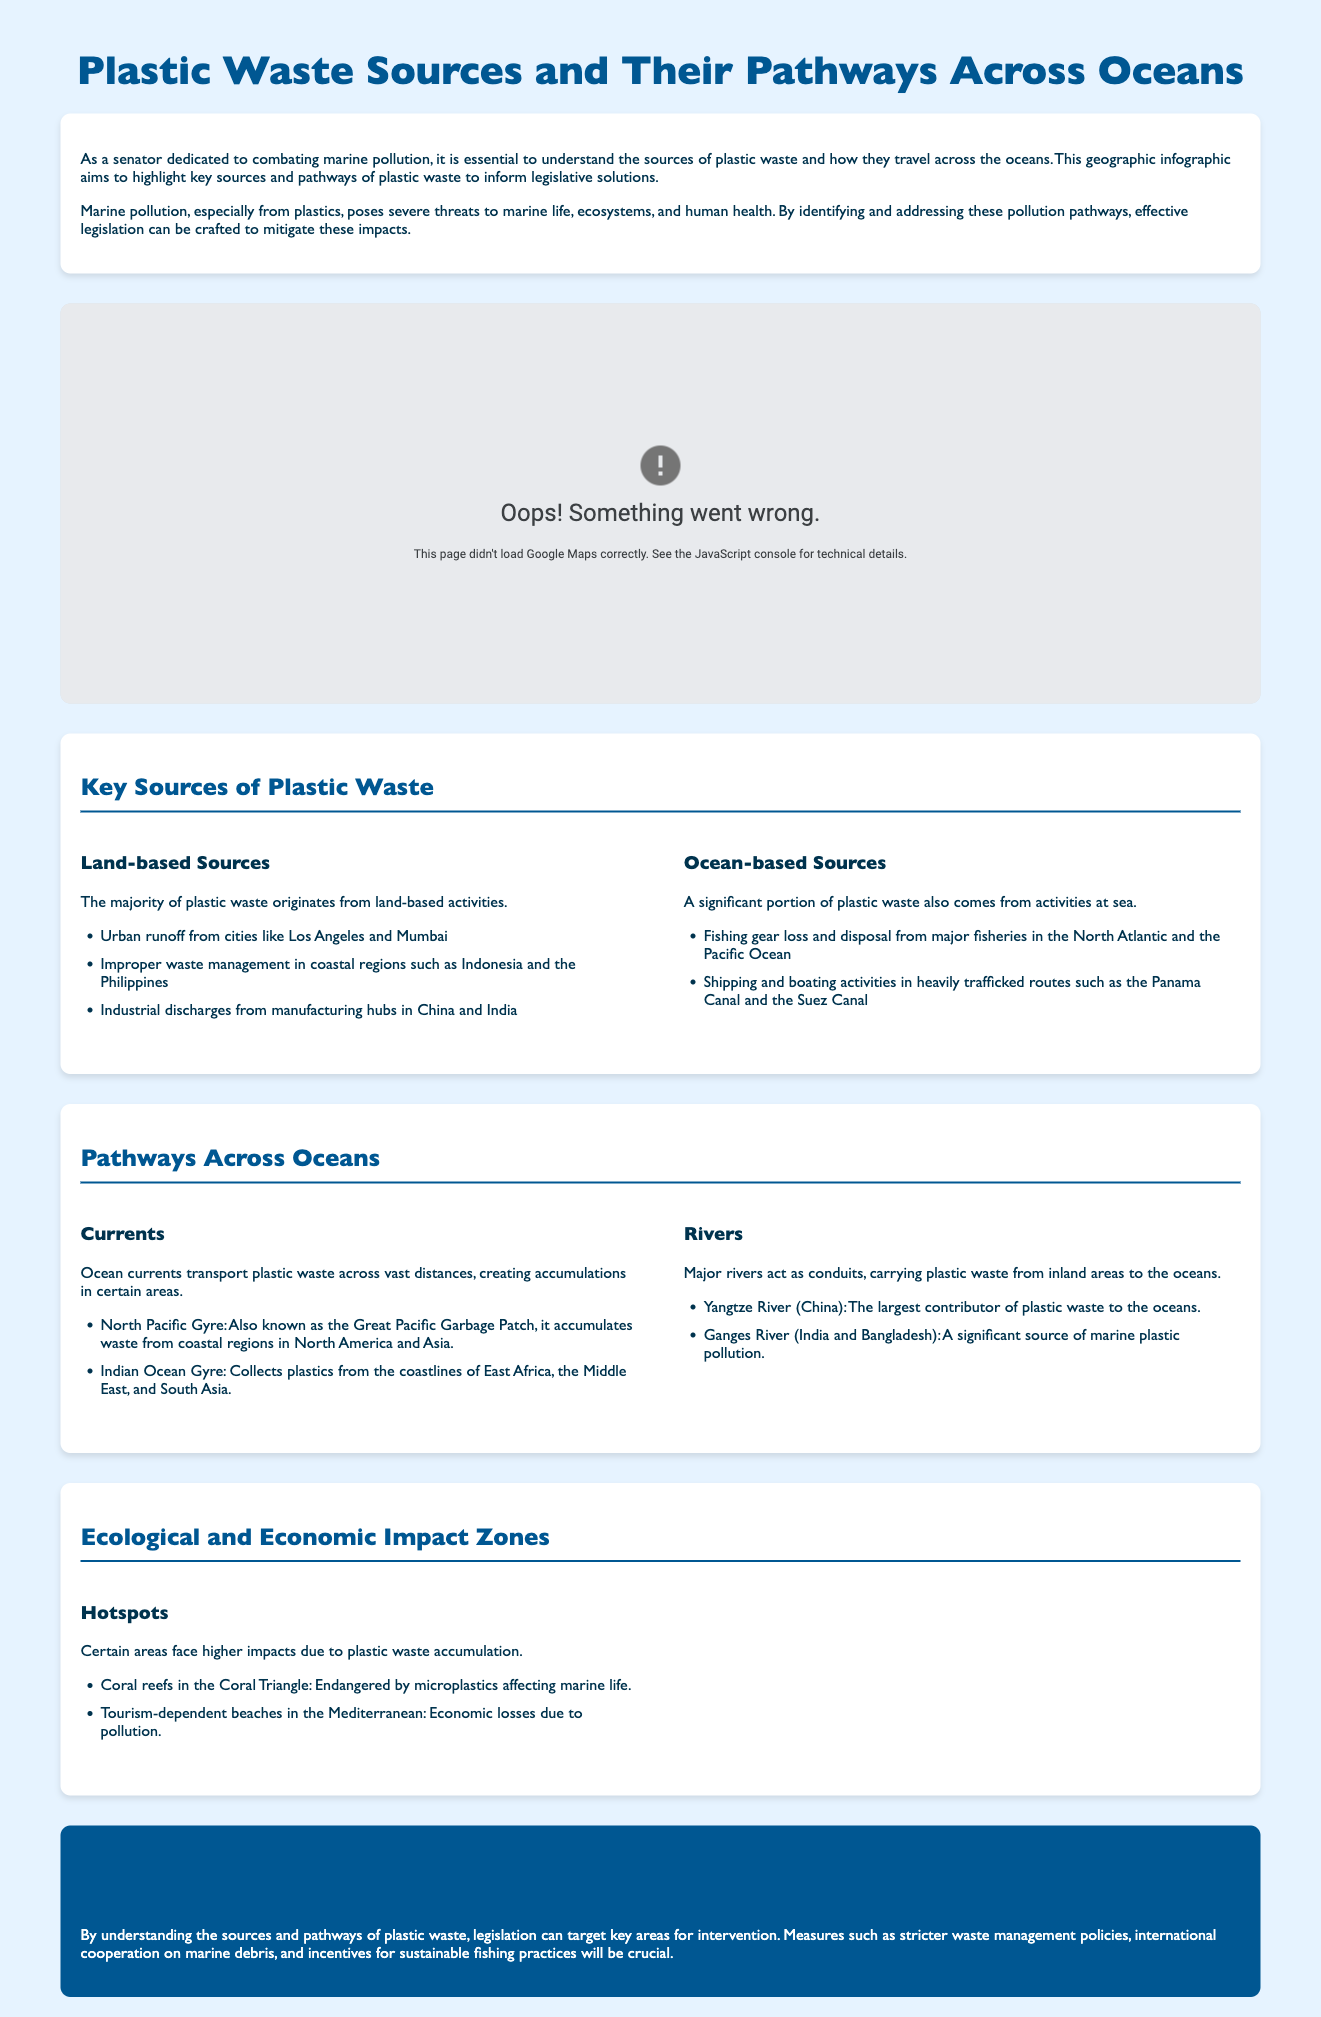What is the main topic of the infographic? The main topic is about the sources and pathways of plastic waste across oceans, detailing marine pollution.
Answer: Plastic Waste Sources and Their Pathways Across Oceans What are the two key categories of plastic waste sources mentioned? The document specifies land-based and ocean-based sources as key categories.
Answer: Land-based and Ocean-based Sources Which river is noted as the largest contributor of plastic waste to the oceans? The Yangtze River is highlighted as the largest contributor, as mentioned in the pathways section of the document.
Answer: Yangtze River What area is referred to as the Great Pacific Garbage Patch? The infographic describes it as part of the North Pacific Gyre, which accumulates waste from coastal regions.
Answer: North Pacific Gyre Which countries are listed under improper waste management in coastal regions? Indonesia and the Philippines are given as examples of countries facing improper waste management.
Answer: Indonesia and the Philippines What ecological zone is facing significant impact from microplastics? Coral reefs in the Coral Triangle are indicated as facing higher threats from microplastics.
Answer: Coral Triangle What is emphasized as a crucial legislative measure? Stricter waste management policies are noted as a critical measure to combat marine pollution.
Answer: Stricter waste management policies Which ocean is identified as collecting plastics from East Africa, the Middle East, and South Asia? The Indian Ocean Gyre is mentioned as a significant area for collecting plastics from those regions.
Answer: Indian Ocean Gyre What is the economic impact highlighted in tourism-dependent areas? The Mediterranean is identified as facing economic losses due to pollution affecting its beaches.
Answer: Mediterranean 